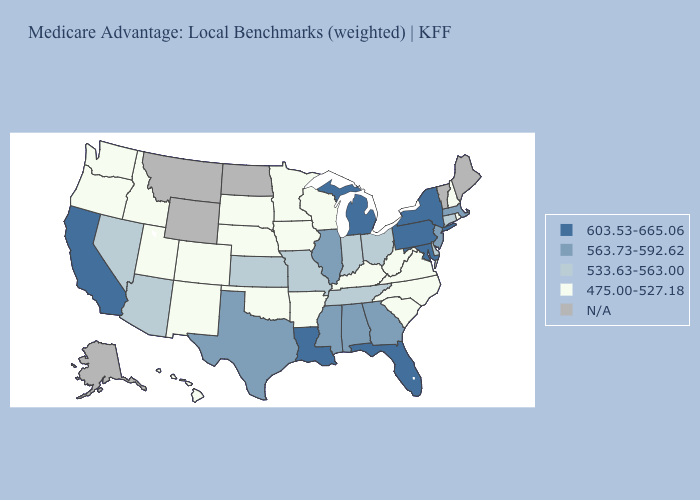Does New Jersey have the lowest value in the Northeast?
Short answer required. No. What is the value of North Carolina?
Be succinct. 475.00-527.18. Does Maryland have the lowest value in the USA?
Give a very brief answer. No. Which states have the lowest value in the USA?
Be succinct. Arkansas, Colorado, Hawaii, Iowa, Idaho, Kentucky, Minnesota, North Carolina, Nebraska, New Hampshire, New Mexico, Oklahoma, Oregon, Rhode Island, South Carolina, South Dakota, Utah, Virginia, Washington, Wisconsin, West Virginia. Name the states that have a value in the range 475.00-527.18?
Concise answer only. Arkansas, Colorado, Hawaii, Iowa, Idaho, Kentucky, Minnesota, North Carolina, Nebraska, New Hampshire, New Mexico, Oklahoma, Oregon, Rhode Island, South Carolina, South Dakota, Utah, Virginia, Washington, Wisconsin, West Virginia. Name the states that have a value in the range N/A?
Answer briefly. Alaska, Maine, Montana, North Dakota, Vermont, Wyoming. What is the value of Connecticut?
Write a very short answer. 533.63-563.00. Among the states that border Utah , does New Mexico have the lowest value?
Give a very brief answer. Yes. What is the value of Maryland?
Give a very brief answer. 603.53-665.06. Name the states that have a value in the range 563.73-592.62?
Quick response, please. Alabama, Georgia, Illinois, Massachusetts, Mississippi, New Jersey, Texas. Name the states that have a value in the range 533.63-563.00?
Keep it brief. Arizona, Connecticut, Delaware, Indiana, Kansas, Missouri, Nevada, Ohio, Tennessee. Name the states that have a value in the range N/A?
Answer briefly. Alaska, Maine, Montana, North Dakota, Vermont, Wyoming. What is the value of Iowa?
Short answer required. 475.00-527.18. What is the lowest value in the USA?
Write a very short answer. 475.00-527.18. Name the states that have a value in the range 475.00-527.18?
Concise answer only. Arkansas, Colorado, Hawaii, Iowa, Idaho, Kentucky, Minnesota, North Carolina, Nebraska, New Hampshire, New Mexico, Oklahoma, Oregon, Rhode Island, South Carolina, South Dakota, Utah, Virginia, Washington, Wisconsin, West Virginia. 